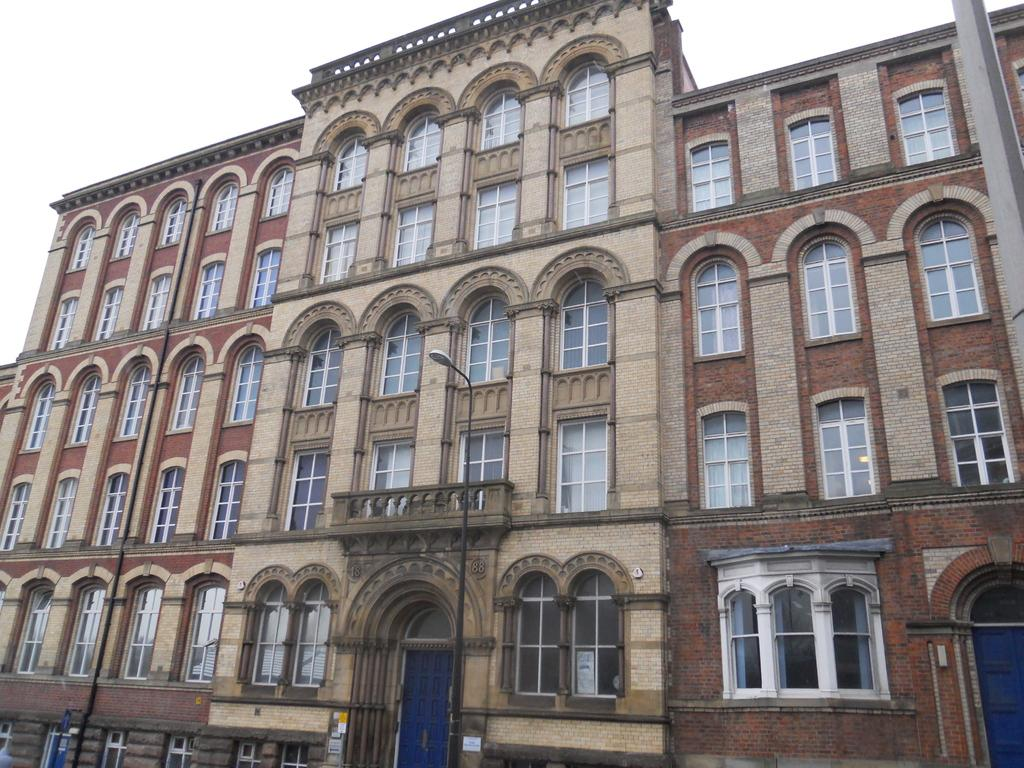What type of structures are present in the image? There are buildings with windows in the image. What features do the buildings have? The buildings have doors. What else can be seen in the image besides the buildings? There is a pole in the image. What is visible in the background of the image? The sky is visible in the image. What type of snake can be seen slithering through the windows of the buildings in the image? There is no snake present in the image; the buildings have windows, but no snake is visible. 